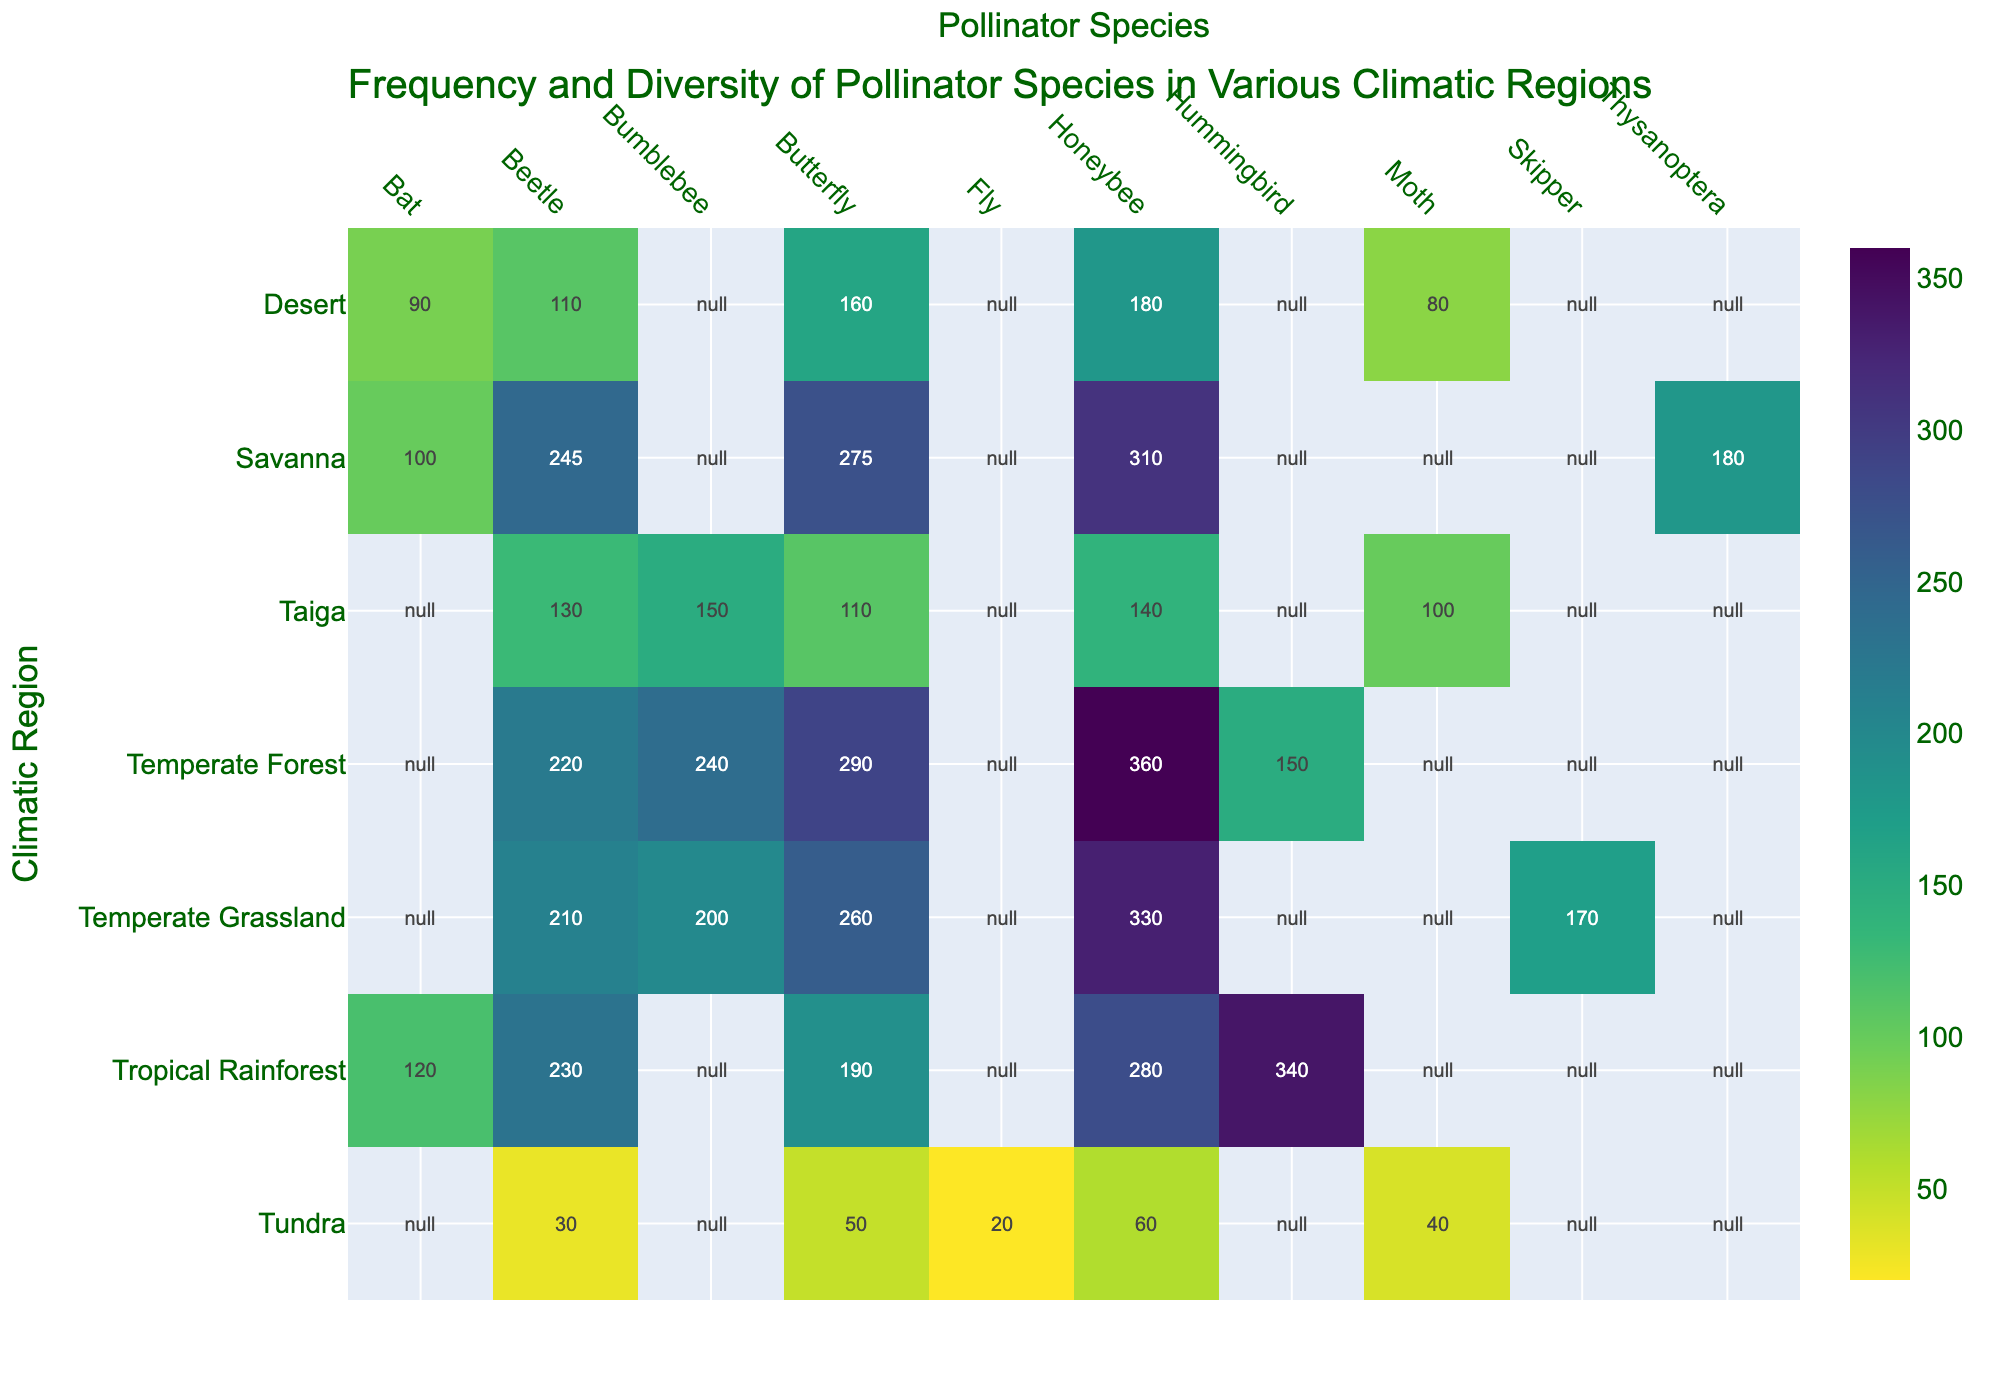What's the title of the figure? The title is located at the top of the figure and is often brief and descriptive of the data being shown.
Answer: Frequency and Diversity of Pollinator Species in Various Climatic Regions Which climatic region has the highest frequency of Hummingbird pollinators? By examining the vertical position of Hummingbird in the heatmap and following along the rows, it can be determined that Tropical Rainforest has the highest frequency.
Answer: Tropical Rainforest What's the combined frequency of Honeybees across all regions? Adding up the frequencies of Honeybees across all regions: 280 (Tropical Rainforest) + 310 (Savanna) + 360 (Temperate Forest) + 330 (Temperate Grassland) + 180 (Desert) + 140 (Taiga) + 60 (Tundra) = 1660.
Answer: 1660 In which climatic region is the frequency of Butterflies higher: Taiga or Tundra? Find the positions specific to Butterflies within Taiga and Tundra. Compare the numbers: 110 (Taiga) vs 50 (Tundra).
Answer: Taiga What's the average frequency of pollinator species in the Desert region? Sum the frequencies of all pollinator species in the Desert and divide by the number of species: (180 + 160 + 90 + 110 + 80)/5 = 124
Answer: 124 Which climatic region has the most diverse set of pollinator species? Diversity can be gauged by the number of different species listed for each region. Tropical Rainforest lists five species: Hummingbird, Honeybee, Butterfly, Bat, Beetle.
Answer: Tropical Rainforest What's the numerical difference in Bumblebee frequency between Temperate Forest and Temperate Grassland? Subtract the frequency of Bumblebees in Temperate Grassland from its frequency in Temperate Forest: 240 (Temperate Forest) - 200 (Temperate Grassland) = 40.
Answer: 40 Which pollinator species has the lowest overall frequency in the Tundra region? Look through the frequencies listed for Tundra: 60 (Honeybee), 50 (Butterfly), 40 (Moth), 30 (Beetle), 20 (Fly).
Answer: Fly Among the regions provided, which has a higher frequency of pollinators overall, Temperate Forest or Savanna? Calculate the total frequencies for each region: Temperate Forest (360+290+240+220+150)=1260; Savanna (310+275+245+180+100)=1110; Compare the totals.
Answer: Temperate Forest 